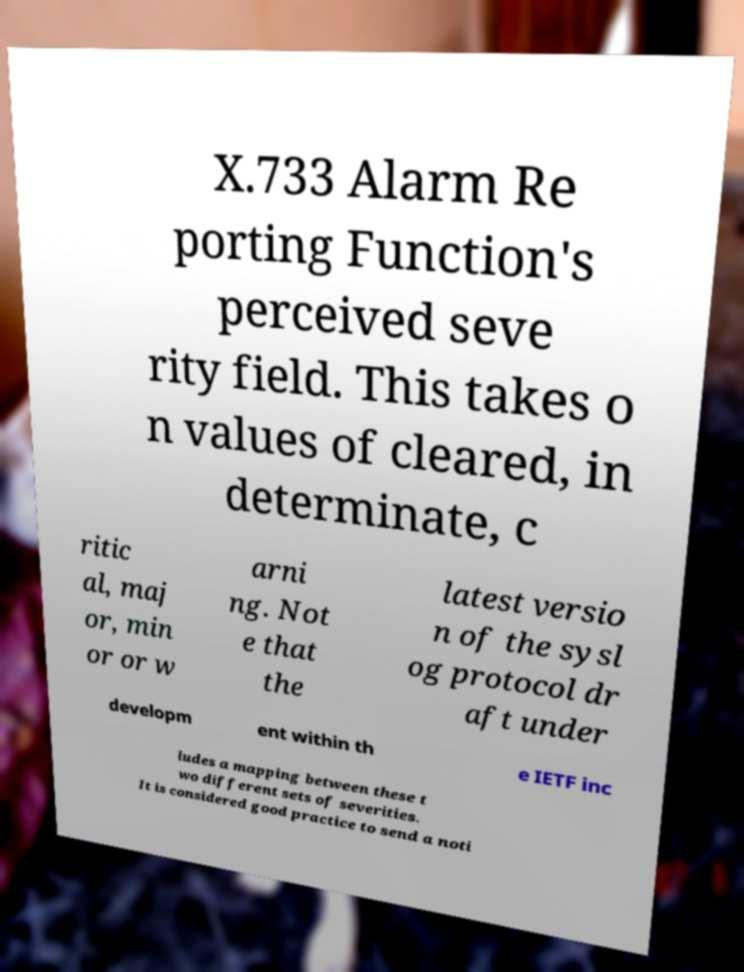Could you extract and type out the text from this image? X.733 Alarm Re porting Function's perceived seve rity field. This takes o n values of cleared, in determinate, c ritic al, maj or, min or or w arni ng. Not e that the latest versio n of the sysl og protocol dr aft under developm ent within th e IETF inc ludes a mapping between these t wo different sets of severities. It is considered good practice to send a noti 